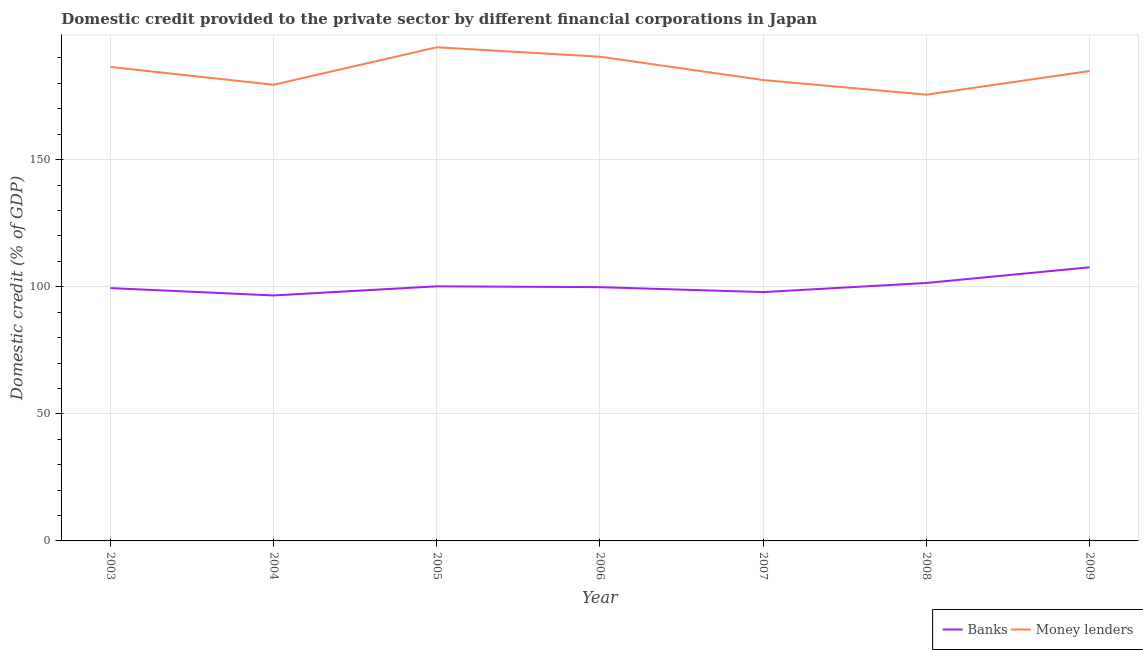How many different coloured lines are there?
Ensure brevity in your answer.  2. Does the line corresponding to domestic credit provided by banks intersect with the line corresponding to domestic credit provided by money lenders?
Offer a terse response. No. Is the number of lines equal to the number of legend labels?
Your answer should be very brief. Yes. What is the domestic credit provided by banks in 2007?
Offer a terse response. 97.9. Across all years, what is the maximum domestic credit provided by banks?
Give a very brief answer. 107.65. Across all years, what is the minimum domestic credit provided by banks?
Make the answer very short. 96.58. In which year was the domestic credit provided by banks minimum?
Make the answer very short. 2004. What is the total domestic credit provided by money lenders in the graph?
Your answer should be very brief. 1292.45. What is the difference between the domestic credit provided by banks in 2003 and that in 2004?
Keep it short and to the point. 2.9. What is the difference between the domestic credit provided by banks in 2005 and the domestic credit provided by money lenders in 2006?
Your response must be concise. -90.34. What is the average domestic credit provided by money lenders per year?
Make the answer very short. 184.64. In the year 2007, what is the difference between the domestic credit provided by money lenders and domestic credit provided by banks?
Your response must be concise. 83.43. What is the ratio of the domestic credit provided by banks in 2005 to that in 2008?
Provide a short and direct response. 0.99. Is the domestic credit provided by banks in 2005 less than that in 2008?
Ensure brevity in your answer.  Yes. Is the difference between the domestic credit provided by banks in 2008 and 2009 greater than the difference between the domestic credit provided by money lenders in 2008 and 2009?
Provide a short and direct response. Yes. What is the difference between the highest and the second highest domestic credit provided by banks?
Provide a short and direct response. 6.17. What is the difference between the highest and the lowest domestic credit provided by banks?
Provide a short and direct response. 11.07. Is the sum of the domestic credit provided by banks in 2006 and 2008 greater than the maximum domestic credit provided by money lenders across all years?
Offer a terse response. Yes. Does the domestic credit provided by banks monotonically increase over the years?
Make the answer very short. No. Is the domestic credit provided by banks strictly greater than the domestic credit provided by money lenders over the years?
Offer a very short reply. No. How many lines are there?
Offer a terse response. 2. How many years are there in the graph?
Keep it short and to the point. 7. Does the graph contain grids?
Keep it short and to the point. Yes. Where does the legend appear in the graph?
Provide a short and direct response. Bottom right. How many legend labels are there?
Provide a succinct answer. 2. What is the title of the graph?
Your answer should be very brief. Domestic credit provided to the private sector by different financial corporations in Japan. Does "Ages 15-24" appear as one of the legend labels in the graph?
Keep it short and to the point. No. What is the label or title of the Y-axis?
Provide a short and direct response. Domestic credit (% of GDP). What is the Domestic credit (% of GDP) of Banks in 2003?
Ensure brevity in your answer.  99.47. What is the Domestic credit (% of GDP) of Money lenders in 2003?
Offer a terse response. 186.47. What is the Domestic credit (% of GDP) of Banks in 2004?
Your response must be concise. 96.58. What is the Domestic credit (% of GDP) in Money lenders in 2004?
Provide a succinct answer. 179.48. What is the Domestic credit (% of GDP) of Banks in 2005?
Give a very brief answer. 100.17. What is the Domestic credit (% of GDP) in Money lenders in 2005?
Give a very brief answer. 194.21. What is the Domestic credit (% of GDP) in Banks in 2006?
Your answer should be compact. 99.84. What is the Domestic credit (% of GDP) of Money lenders in 2006?
Your answer should be compact. 190.51. What is the Domestic credit (% of GDP) in Banks in 2007?
Your answer should be compact. 97.9. What is the Domestic credit (% of GDP) of Money lenders in 2007?
Keep it short and to the point. 181.33. What is the Domestic credit (% of GDP) of Banks in 2008?
Offer a terse response. 101.48. What is the Domestic credit (% of GDP) of Money lenders in 2008?
Your response must be concise. 175.57. What is the Domestic credit (% of GDP) in Banks in 2009?
Offer a terse response. 107.65. What is the Domestic credit (% of GDP) of Money lenders in 2009?
Your answer should be compact. 184.87. Across all years, what is the maximum Domestic credit (% of GDP) in Banks?
Ensure brevity in your answer.  107.65. Across all years, what is the maximum Domestic credit (% of GDP) in Money lenders?
Your answer should be compact. 194.21. Across all years, what is the minimum Domestic credit (% of GDP) in Banks?
Give a very brief answer. 96.58. Across all years, what is the minimum Domestic credit (% of GDP) in Money lenders?
Offer a very short reply. 175.57. What is the total Domestic credit (% of GDP) of Banks in the graph?
Your answer should be very brief. 703.09. What is the total Domestic credit (% of GDP) in Money lenders in the graph?
Give a very brief answer. 1292.45. What is the difference between the Domestic credit (% of GDP) in Banks in 2003 and that in 2004?
Give a very brief answer. 2.9. What is the difference between the Domestic credit (% of GDP) of Money lenders in 2003 and that in 2004?
Provide a succinct answer. 7. What is the difference between the Domestic credit (% of GDP) in Banks in 2003 and that in 2005?
Your answer should be compact. -0.7. What is the difference between the Domestic credit (% of GDP) of Money lenders in 2003 and that in 2005?
Your answer should be very brief. -7.74. What is the difference between the Domestic credit (% of GDP) in Banks in 2003 and that in 2006?
Your answer should be compact. -0.36. What is the difference between the Domestic credit (% of GDP) of Money lenders in 2003 and that in 2006?
Ensure brevity in your answer.  -4.03. What is the difference between the Domestic credit (% of GDP) of Banks in 2003 and that in 2007?
Offer a very short reply. 1.58. What is the difference between the Domestic credit (% of GDP) of Money lenders in 2003 and that in 2007?
Provide a succinct answer. 5.14. What is the difference between the Domestic credit (% of GDP) of Banks in 2003 and that in 2008?
Keep it short and to the point. -2.01. What is the difference between the Domestic credit (% of GDP) in Money lenders in 2003 and that in 2008?
Provide a succinct answer. 10.9. What is the difference between the Domestic credit (% of GDP) of Banks in 2003 and that in 2009?
Your answer should be compact. -8.18. What is the difference between the Domestic credit (% of GDP) in Money lenders in 2003 and that in 2009?
Your answer should be compact. 1.6. What is the difference between the Domestic credit (% of GDP) of Banks in 2004 and that in 2005?
Your response must be concise. -3.59. What is the difference between the Domestic credit (% of GDP) of Money lenders in 2004 and that in 2005?
Ensure brevity in your answer.  -14.74. What is the difference between the Domestic credit (% of GDP) in Banks in 2004 and that in 2006?
Provide a short and direct response. -3.26. What is the difference between the Domestic credit (% of GDP) in Money lenders in 2004 and that in 2006?
Offer a very short reply. -11.03. What is the difference between the Domestic credit (% of GDP) of Banks in 2004 and that in 2007?
Give a very brief answer. -1.32. What is the difference between the Domestic credit (% of GDP) of Money lenders in 2004 and that in 2007?
Your answer should be very brief. -1.85. What is the difference between the Domestic credit (% of GDP) in Banks in 2004 and that in 2008?
Your answer should be compact. -4.91. What is the difference between the Domestic credit (% of GDP) of Money lenders in 2004 and that in 2008?
Keep it short and to the point. 3.91. What is the difference between the Domestic credit (% of GDP) in Banks in 2004 and that in 2009?
Your answer should be compact. -11.07. What is the difference between the Domestic credit (% of GDP) in Money lenders in 2004 and that in 2009?
Keep it short and to the point. -5.4. What is the difference between the Domestic credit (% of GDP) in Banks in 2005 and that in 2006?
Offer a very short reply. 0.34. What is the difference between the Domestic credit (% of GDP) of Money lenders in 2005 and that in 2006?
Your response must be concise. 3.71. What is the difference between the Domestic credit (% of GDP) of Banks in 2005 and that in 2007?
Your answer should be compact. 2.27. What is the difference between the Domestic credit (% of GDP) of Money lenders in 2005 and that in 2007?
Keep it short and to the point. 12.88. What is the difference between the Domestic credit (% of GDP) of Banks in 2005 and that in 2008?
Your response must be concise. -1.31. What is the difference between the Domestic credit (% of GDP) of Money lenders in 2005 and that in 2008?
Your answer should be compact. 18.64. What is the difference between the Domestic credit (% of GDP) of Banks in 2005 and that in 2009?
Offer a very short reply. -7.48. What is the difference between the Domestic credit (% of GDP) of Money lenders in 2005 and that in 2009?
Make the answer very short. 9.34. What is the difference between the Domestic credit (% of GDP) of Banks in 2006 and that in 2007?
Provide a succinct answer. 1.94. What is the difference between the Domestic credit (% of GDP) of Money lenders in 2006 and that in 2007?
Your answer should be very brief. 9.18. What is the difference between the Domestic credit (% of GDP) of Banks in 2006 and that in 2008?
Provide a short and direct response. -1.65. What is the difference between the Domestic credit (% of GDP) of Money lenders in 2006 and that in 2008?
Provide a short and direct response. 14.94. What is the difference between the Domestic credit (% of GDP) of Banks in 2006 and that in 2009?
Ensure brevity in your answer.  -7.82. What is the difference between the Domestic credit (% of GDP) of Money lenders in 2006 and that in 2009?
Offer a very short reply. 5.63. What is the difference between the Domestic credit (% of GDP) of Banks in 2007 and that in 2008?
Your answer should be very brief. -3.59. What is the difference between the Domestic credit (% of GDP) of Money lenders in 2007 and that in 2008?
Your answer should be very brief. 5.76. What is the difference between the Domestic credit (% of GDP) of Banks in 2007 and that in 2009?
Make the answer very short. -9.75. What is the difference between the Domestic credit (% of GDP) in Money lenders in 2007 and that in 2009?
Give a very brief answer. -3.55. What is the difference between the Domestic credit (% of GDP) of Banks in 2008 and that in 2009?
Give a very brief answer. -6.17. What is the difference between the Domestic credit (% of GDP) in Money lenders in 2008 and that in 2009?
Your response must be concise. -9.3. What is the difference between the Domestic credit (% of GDP) in Banks in 2003 and the Domestic credit (% of GDP) in Money lenders in 2004?
Your response must be concise. -80. What is the difference between the Domestic credit (% of GDP) of Banks in 2003 and the Domestic credit (% of GDP) of Money lenders in 2005?
Make the answer very short. -94.74. What is the difference between the Domestic credit (% of GDP) of Banks in 2003 and the Domestic credit (% of GDP) of Money lenders in 2006?
Your response must be concise. -91.03. What is the difference between the Domestic credit (% of GDP) in Banks in 2003 and the Domestic credit (% of GDP) in Money lenders in 2007?
Your answer should be very brief. -81.86. What is the difference between the Domestic credit (% of GDP) in Banks in 2003 and the Domestic credit (% of GDP) in Money lenders in 2008?
Offer a very short reply. -76.1. What is the difference between the Domestic credit (% of GDP) of Banks in 2003 and the Domestic credit (% of GDP) of Money lenders in 2009?
Offer a terse response. -85.4. What is the difference between the Domestic credit (% of GDP) in Banks in 2004 and the Domestic credit (% of GDP) in Money lenders in 2005?
Make the answer very short. -97.64. What is the difference between the Domestic credit (% of GDP) of Banks in 2004 and the Domestic credit (% of GDP) of Money lenders in 2006?
Provide a succinct answer. -93.93. What is the difference between the Domestic credit (% of GDP) in Banks in 2004 and the Domestic credit (% of GDP) in Money lenders in 2007?
Keep it short and to the point. -84.75. What is the difference between the Domestic credit (% of GDP) of Banks in 2004 and the Domestic credit (% of GDP) of Money lenders in 2008?
Make the answer very short. -78.99. What is the difference between the Domestic credit (% of GDP) of Banks in 2004 and the Domestic credit (% of GDP) of Money lenders in 2009?
Give a very brief answer. -88.3. What is the difference between the Domestic credit (% of GDP) in Banks in 2005 and the Domestic credit (% of GDP) in Money lenders in 2006?
Offer a very short reply. -90.34. What is the difference between the Domestic credit (% of GDP) of Banks in 2005 and the Domestic credit (% of GDP) of Money lenders in 2007?
Keep it short and to the point. -81.16. What is the difference between the Domestic credit (% of GDP) of Banks in 2005 and the Domestic credit (% of GDP) of Money lenders in 2008?
Ensure brevity in your answer.  -75.4. What is the difference between the Domestic credit (% of GDP) of Banks in 2005 and the Domestic credit (% of GDP) of Money lenders in 2009?
Your answer should be compact. -84.7. What is the difference between the Domestic credit (% of GDP) of Banks in 2006 and the Domestic credit (% of GDP) of Money lenders in 2007?
Ensure brevity in your answer.  -81.49. What is the difference between the Domestic credit (% of GDP) of Banks in 2006 and the Domestic credit (% of GDP) of Money lenders in 2008?
Make the answer very short. -75.74. What is the difference between the Domestic credit (% of GDP) in Banks in 2006 and the Domestic credit (% of GDP) in Money lenders in 2009?
Provide a short and direct response. -85.04. What is the difference between the Domestic credit (% of GDP) in Banks in 2007 and the Domestic credit (% of GDP) in Money lenders in 2008?
Ensure brevity in your answer.  -77.67. What is the difference between the Domestic credit (% of GDP) of Banks in 2007 and the Domestic credit (% of GDP) of Money lenders in 2009?
Provide a short and direct response. -86.98. What is the difference between the Domestic credit (% of GDP) of Banks in 2008 and the Domestic credit (% of GDP) of Money lenders in 2009?
Keep it short and to the point. -83.39. What is the average Domestic credit (% of GDP) in Banks per year?
Provide a succinct answer. 100.44. What is the average Domestic credit (% of GDP) of Money lenders per year?
Provide a succinct answer. 184.64. In the year 2003, what is the difference between the Domestic credit (% of GDP) of Banks and Domestic credit (% of GDP) of Money lenders?
Your answer should be very brief. -87. In the year 2004, what is the difference between the Domestic credit (% of GDP) of Banks and Domestic credit (% of GDP) of Money lenders?
Your answer should be compact. -82.9. In the year 2005, what is the difference between the Domestic credit (% of GDP) in Banks and Domestic credit (% of GDP) in Money lenders?
Keep it short and to the point. -94.04. In the year 2006, what is the difference between the Domestic credit (% of GDP) in Banks and Domestic credit (% of GDP) in Money lenders?
Give a very brief answer. -90.67. In the year 2007, what is the difference between the Domestic credit (% of GDP) in Banks and Domestic credit (% of GDP) in Money lenders?
Your answer should be compact. -83.43. In the year 2008, what is the difference between the Domestic credit (% of GDP) of Banks and Domestic credit (% of GDP) of Money lenders?
Provide a succinct answer. -74.09. In the year 2009, what is the difference between the Domestic credit (% of GDP) of Banks and Domestic credit (% of GDP) of Money lenders?
Ensure brevity in your answer.  -77.22. What is the ratio of the Domestic credit (% of GDP) in Banks in 2003 to that in 2004?
Provide a succinct answer. 1.03. What is the ratio of the Domestic credit (% of GDP) in Money lenders in 2003 to that in 2004?
Your answer should be very brief. 1.04. What is the ratio of the Domestic credit (% of GDP) of Banks in 2003 to that in 2005?
Give a very brief answer. 0.99. What is the ratio of the Domestic credit (% of GDP) in Money lenders in 2003 to that in 2005?
Offer a terse response. 0.96. What is the ratio of the Domestic credit (% of GDP) in Banks in 2003 to that in 2006?
Give a very brief answer. 1. What is the ratio of the Domestic credit (% of GDP) in Money lenders in 2003 to that in 2006?
Your response must be concise. 0.98. What is the ratio of the Domestic credit (% of GDP) in Banks in 2003 to that in 2007?
Your answer should be compact. 1.02. What is the ratio of the Domestic credit (% of GDP) in Money lenders in 2003 to that in 2007?
Provide a succinct answer. 1.03. What is the ratio of the Domestic credit (% of GDP) in Banks in 2003 to that in 2008?
Give a very brief answer. 0.98. What is the ratio of the Domestic credit (% of GDP) of Money lenders in 2003 to that in 2008?
Provide a succinct answer. 1.06. What is the ratio of the Domestic credit (% of GDP) of Banks in 2003 to that in 2009?
Your answer should be compact. 0.92. What is the ratio of the Domestic credit (% of GDP) in Money lenders in 2003 to that in 2009?
Provide a short and direct response. 1.01. What is the ratio of the Domestic credit (% of GDP) in Banks in 2004 to that in 2005?
Offer a very short reply. 0.96. What is the ratio of the Domestic credit (% of GDP) in Money lenders in 2004 to that in 2005?
Keep it short and to the point. 0.92. What is the ratio of the Domestic credit (% of GDP) of Banks in 2004 to that in 2006?
Keep it short and to the point. 0.97. What is the ratio of the Domestic credit (% of GDP) in Money lenders in 2004 to that in 2006?
Provide a short and direct response. 0.94. What is the ratio of the Domestic credit (% of GDP) in Banks in 2004 to that in 2007?
Your answer should be very brief. 0.99. What is the ratio of the Domestic credit (% of GDP) of Banks in 2004 to that in 2008?
Offer a very short reply. 0.95. What is the ratio of the Domestic credit (% of GDP) in Money lenders in 2004 to that in 2008?
Your answer should be very brief. 1.02. What is the ratio of the Domestic credit (% of GDP) of Banks in 2004 to that in 2009?
Ensure brevity in your answer.  0.9. What is the ratio of the Domestic credit (% of GDP) in Money lenders in 2004 to that in 2009?
Your answer should be compact. 0.97. What is the ratio of the Domestic credit (% of GDP) of Money lenders in 2005 to that in 2006?
Your answer should be compact. 1.02. What is the ratio of the Domestic credit (% of GDP) of Banks in 2005 to that in 2007?
Your answer should be very brief. 1.02. What is the ratio of the Domestic credit (% of GDP) of Money lenders in 2005 to that in 2007?
Give a very brief answer. 1.07. What is the ratio of the Domestic credit (% of GDP) of Banks in 2005 to that in 2008?
Your response must be concise. 0.99. What is the ratio of the Domestic credit (% of GDP) in Money lenders in 2005 to that in 2008?
Provide a short and direct response. 1.11. What is the ratio of the Domestic credit (% of GDP) in Banks in 2005 to that in 2009?
Keep it short and to the point. 0.93. What is the ratio of the Domestic credit (% of GDP) of Money lenders in 2005 to that in 2009?
Offer a very short reply. 1.05. What is the ratio of the Domestic credit (% of GDP) in Banks in 2006 to that in 2007?
Provide a short and direct response. 1.02. What is the ratio of the Domestic credit (% of GDP) of Money lenders in 2006 to that in 2007?
Your answer should be compact. 1.05. What is the ratio of the Domestic credit (% of GDP) in Banks in 2006 to that in 2008?
Make the answer very short. 0.98. What is the ratio of the Domestic credit (% of GDP) in Money lenders in 2006 to that in 2008?
Your response must be concise. 1.09. What is the ratio of the Domestic credit (% of GDP) in Banks in 2006 to that in 2009?
Make the answer very short. 0.93. What is the ratio of the Domestic credit (% of GDP) in Money lenders in 2006 to that in 2009?
Your answer should be very brief. 1.03. What is the ratio of the Domestic credit (% of GDP) in Banks in 2007 to that in 2008?
Ensure brevity in your answer.  0.96. What is the ratio of the Domestic credit (% of GDP) of Money lenders in 2007 to that in 2008?
Your answer should be compact. 1.03. What is the ratio of the Domestic credit (% of GDP) in Banks in 2007 to that in 2009?
Your answer should be very brief. 0.91. What is the ratio of the Domestic credit (% of GDP) of Money lenders in 2007 to that in 2009?
Give a very brief answer. 0.98. What is the ratio of the Domestic credit (% of GDP) of Banks in 2008 to that in 2009?
Make the answer very short. 0.94. What is the ratio of the Domestic credit (% of GDP) in Money lenders in 2008 to that in 2009?
Your answer should be very brief. 0.95. What is the difference between the highest and the second highest Domestic credit (% of GDP) of Banks?
Provide a short and direct response. 6.17. What is the difference between the highest and the second highest Domestic credit (% of GDP) of Money lenders?
Make the answer very short. 3.71. What is the difference between the highest and the lowest Domestic credit (% of GDP) of Banks?
Offer a terse response. 11.07. What is the difference between the highest and the lowest Domestic credit (% of GDP) of Money lenders?
Your response must be concise. 18.64. 